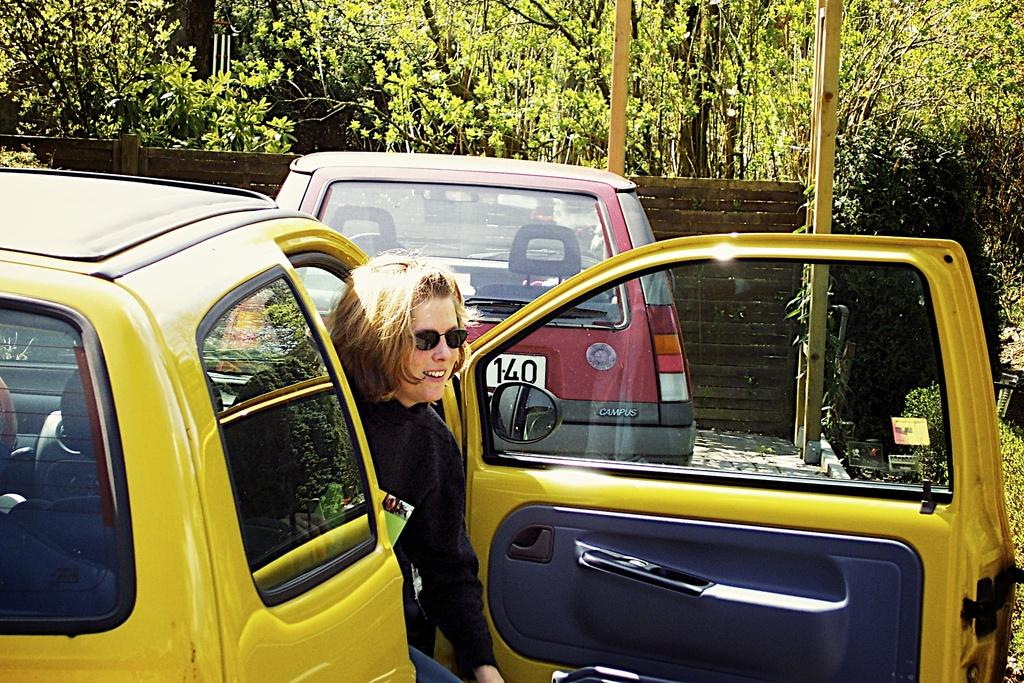<image>
Create a compact narrative representing the image presented. the number 140 on a car and a lady getting out of a car 